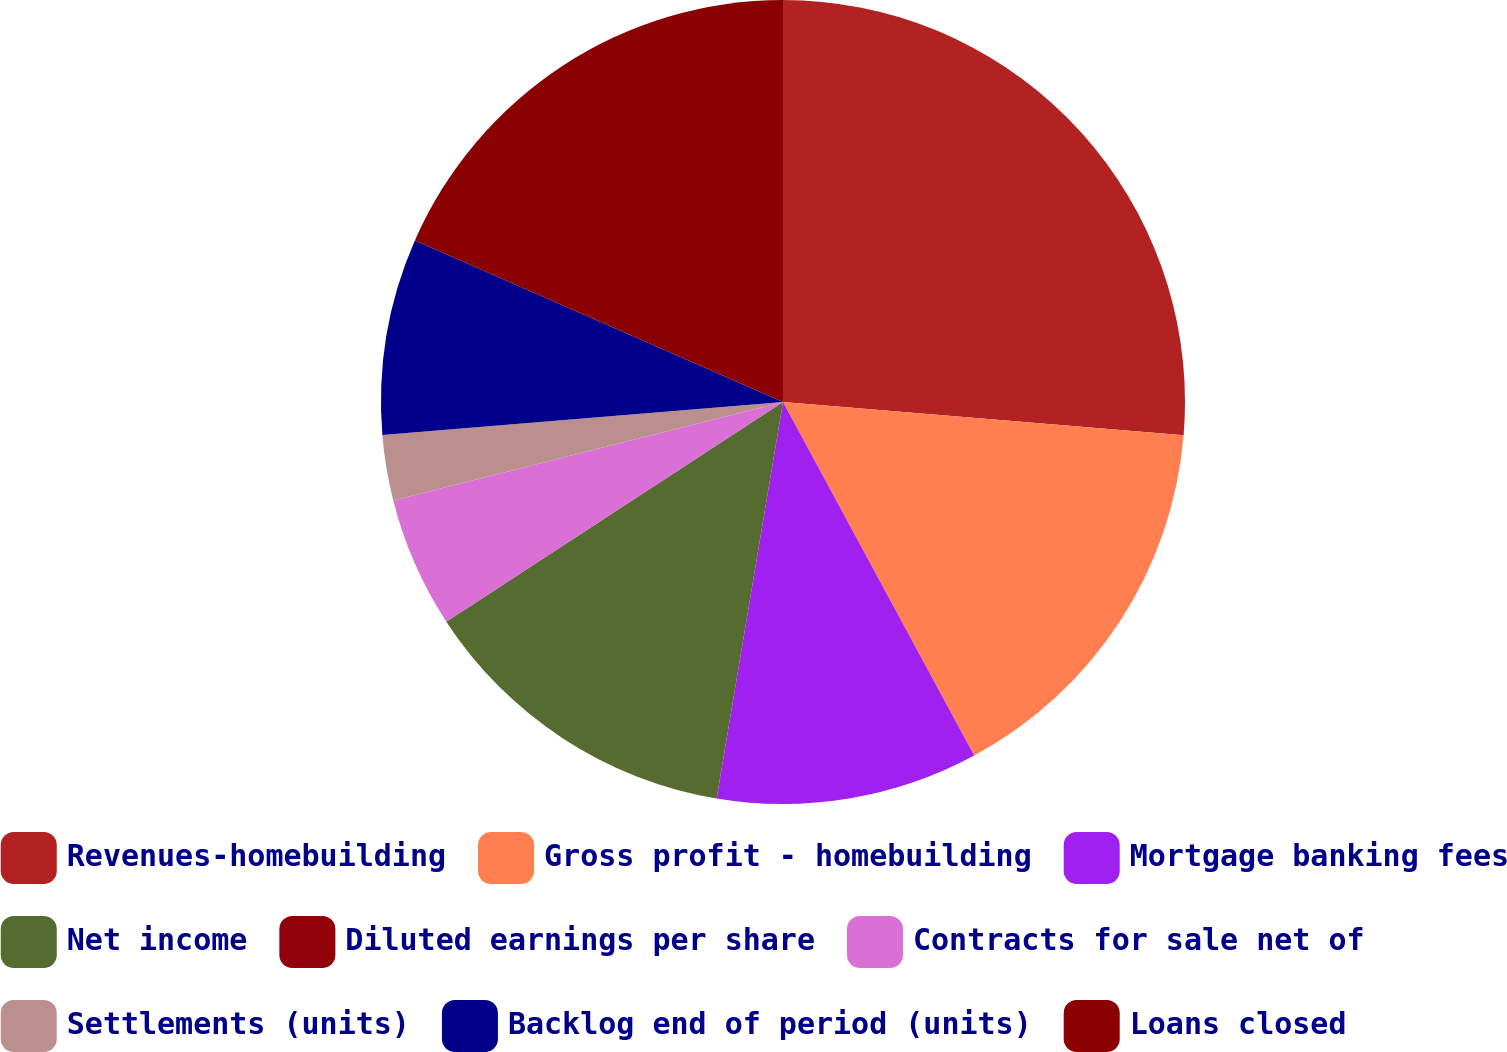Convert chart. <chart><loc_0><loc_0><loc_500><loc_500><pie_chart><fcel>Revenues-homebuilding<fcel>Gross profit - homebuilding<fcel>Mortgage banking fees<fcel>Net income<fcel>Diluted earnings per share<fcel>Contracts for sale net of<fcel>Settlements (units)<fcel>Backlog end of period (units)<fcel>Loans closed<nl><fcel>26.32%<fcel>15.79%<fcel>10.53%<fcel>13.16%<fcel>0.0%<fcel>5.26%<fcel>2.63%<fcel>7.89%<fcel>18.42%<nl></chart> 